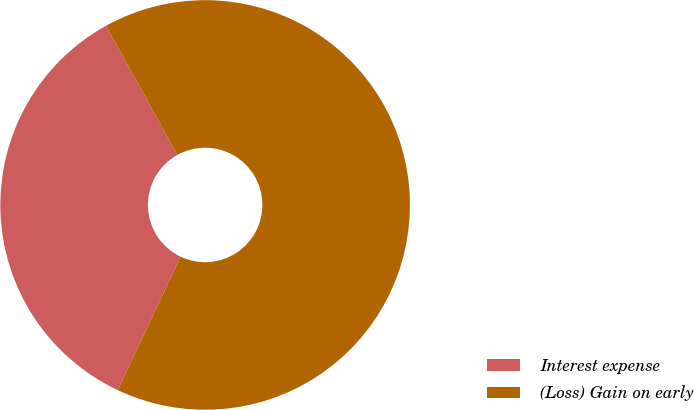Convert chart to OTSL. <chart><loc_0><loc_0><loc_500><loc_500><pie_chart><fcel>Interest expense<fcel>(Loss) Gain on early<nl><fcel>34.93%<fcel>65.07%<nl></chart> 